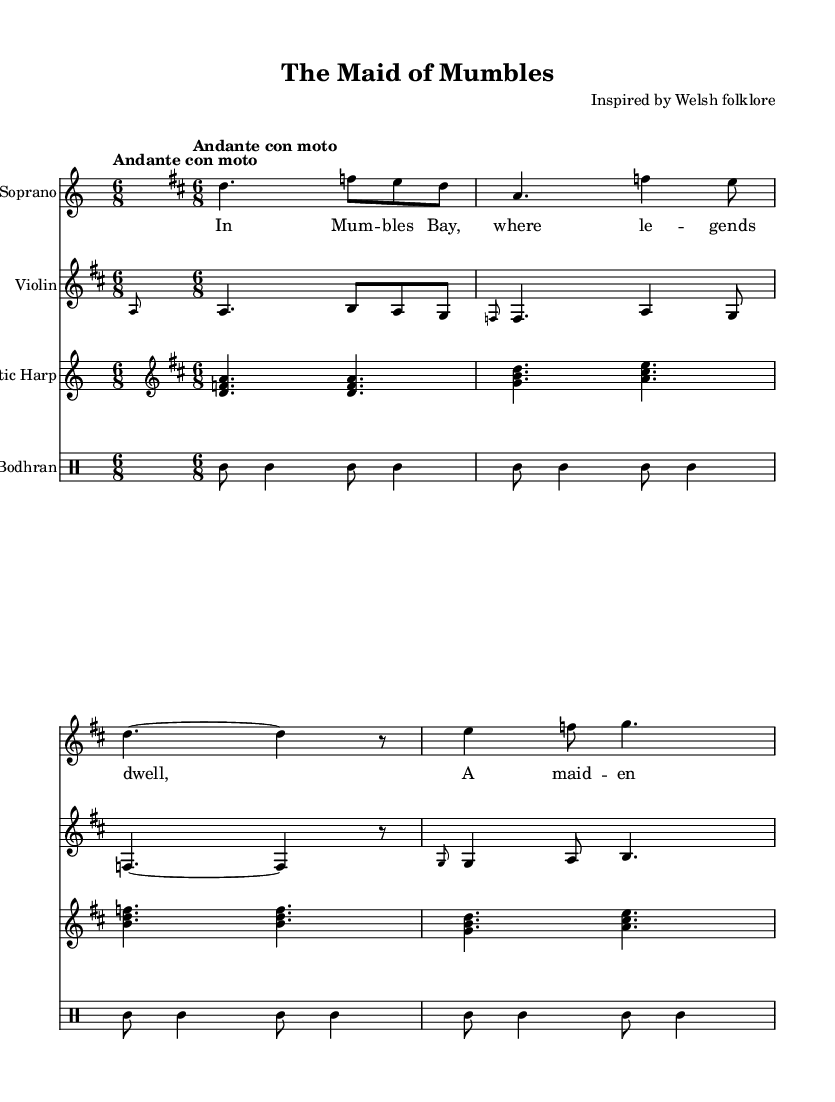What is the key signature of this piece? The key signature is indicated as D major, which has two sharps (F# and C#) on the staff.
Answer: D major What is the time signature? The time signature is noted as 6/8, which means there are six eighth notes per measure.
Answer: 6/8 What is the tempo marking? The tempo marking states "Andante con moto," which suggests a moderately slow tempo with a sense of movement.
Answer: Andante con moto How many instruments are featured in this score? The score includes four instruments: Soprano, Violin, Celtic Harp, and Bodhran.
Answer: Four instruments What are the first two words of the lyrics? The lyrics begin with "In Mum," as observed from the initial part of the lyric section.
Answer: In Mum What instrument plays a melody above the vocal part? The Violin plays a melody that complements the Soprano's vocal line, as seen in the second staff.
Answer: Violin How is the Bodhran part characterized in this score? The Bodhran part is characterized by repetitive rhythmic patterns, indicated by the drum notation below the other instruments.
Answer: Rhythmic patterns 